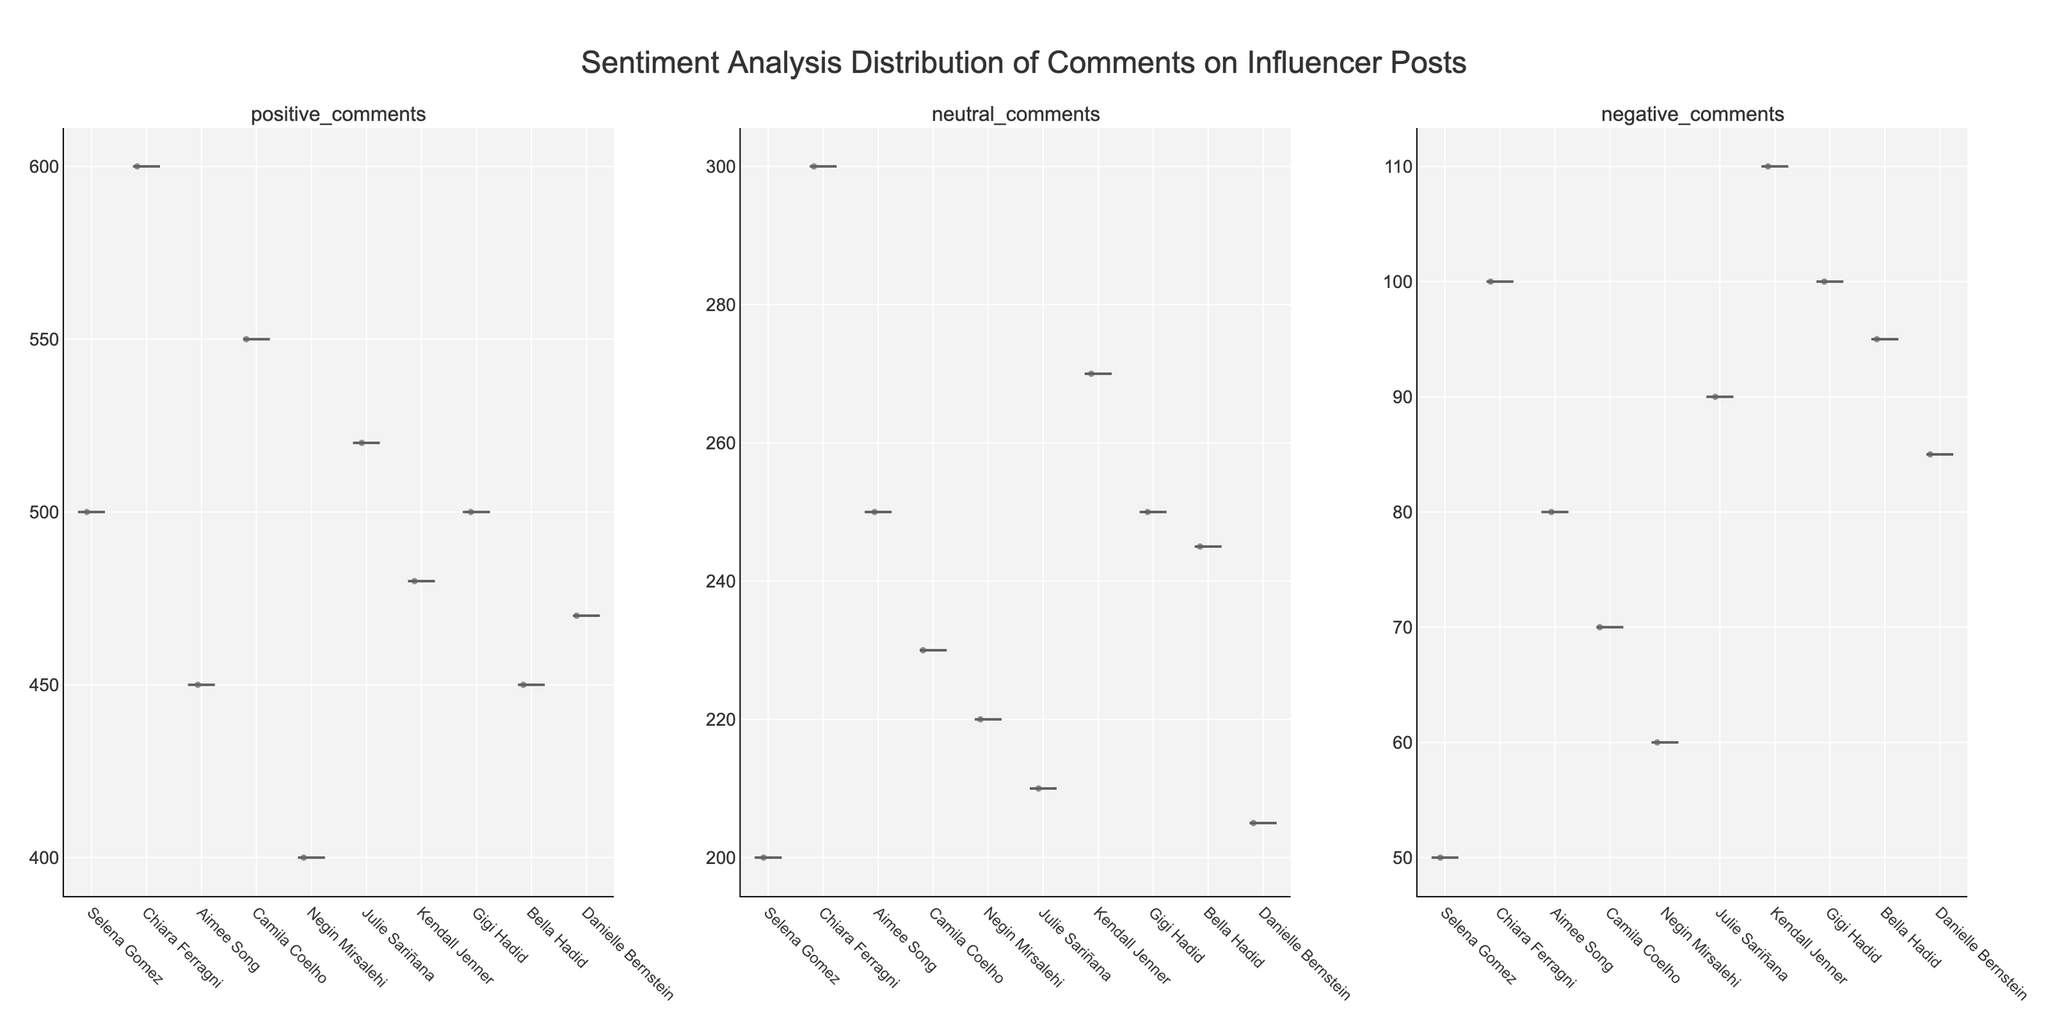What's the title of the figure? The title is located at the top center of the figure, typically in a larger and bold font for emphasis.
Answer: Sentiment Analysis Distribution of Comments on Influencer Posts What sentiment category has the lowest spread of comments for Gigi Hadid? By looking at the width of the violin plots for Gigi Hadid, we can observe that the "Positive Comments" category is the narrowest, indicating the lowest spread.
Answer: Positive Comments Which influencer received the highest number of negative comments? By observing the heights of the "Negative Comments" violin plots across all influencers, Chiara Ferragni's plot is the highest, indicating the most negative comments.
Answer: Chiara Ferragni Compare the number of neutral comments for Negin Mirsalehi and Julie Sariñana. Who received more? By comparing the heights of their respective violin plots for "Neutral Comments", it’s evident that Julie Sariñana's plot is slightly taller than Negin Mirsalehi's.
Answer: Julie Sariñana How does the number of positive comments on Camila Coelho's posts compare to those on Kendall Jenner's posts? By comparing the heights of the "Positive Comments" violin plots between the two influencers, Camila Coelho's plot is higher than Kendall Jenner's.
Answer: Camila Coelho What’s the average number of positive and neutral comments for Aimee Song? To find the average: Aimee Song has 450 positive and 250 neutral comments. Adding these values gives (450 + 250) = 700. Dividing by 2 gives 700/2 = 350.
Answer: 350 Which influencer has a more balanced distribution of comment sentiment categories? A more balanced distribution suggests that the heights of the violin plots for each sentiment category are similar. By checking this, Selena Gomez and Gigi Hadid have more balanced distributions.
Answer: Selena Gomez and Gigi Hadid What is the median number of negative comments on Julie Sariñana's posts? In a violin plot, the median is indicated by a line inside the plot. For Julie Sariñana in the "Negative Comments" category, the line shows that the median is around 90.
Answer: 90 Compare the spread of neutral comments for Chiara Ferragni and Danielle Bernstein. Which has a broader range? By observing the widths of the "Neutral Comments" violin plots, Chiara Ferragni's plot appears wider than Danielle Bernstein's, indicating a broader range.
Answer: Chiara Ferragni Which sentiment category shows the highest variability for Kendall Jenner? The width of the "Negative Comments" violin plot for Kendall Jenner is the widest compared to "Positive" and "Neutral". This indicates the highest variability.
Answer: Negative Comments 